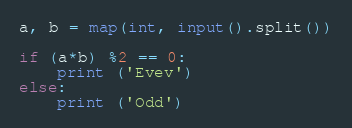Convert code to text. <code><loc_0><loc_0><loc_500><loc_500><_Python_>a, b = map(int, input().split())

if (a*b) %2 == 0:
    print ('Evev')
else:
    print ('Odd')</code> 